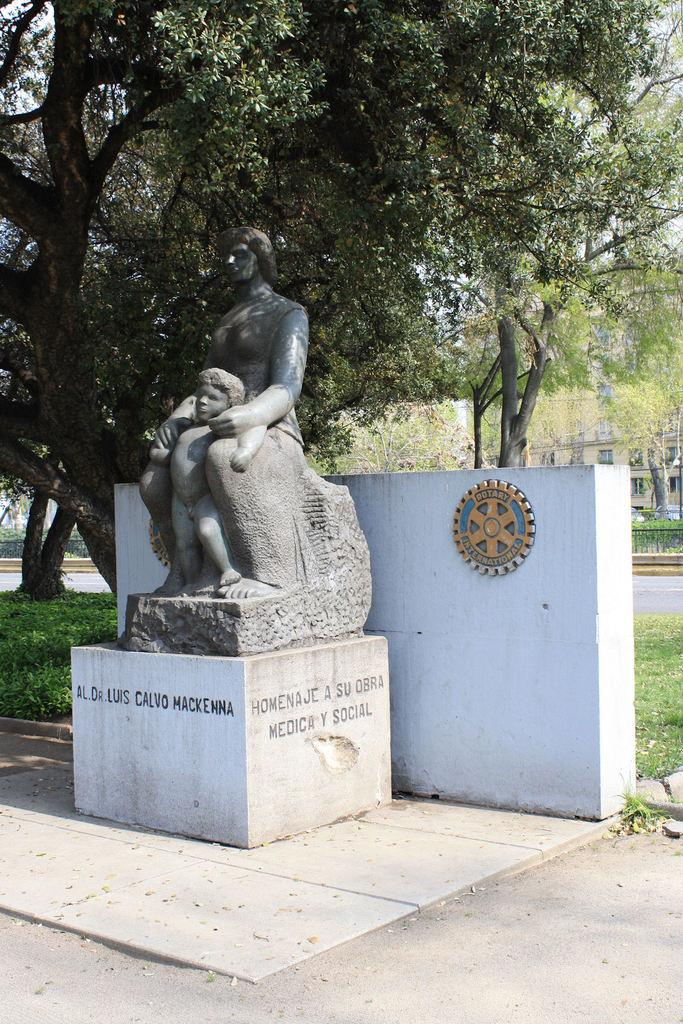What is depicted in the stone sculpture in the image? There is a stone sculpture of a man and a small boy in the image. What is located behind the sculpture? There is a small wall behind the sculpture. What can be seen in the distance in the image? Trees are visible in the background of the image. What type of sound can be heard coming from the rifle in the image? There is no rifle present in the image; it features a stone sculpture of a man and a small boy. How does the comb help in styling the hair of the small boy in the image? There is no comb or hair styling depicted in the image; it only shows a stone sculpture of a man and a small boy. 